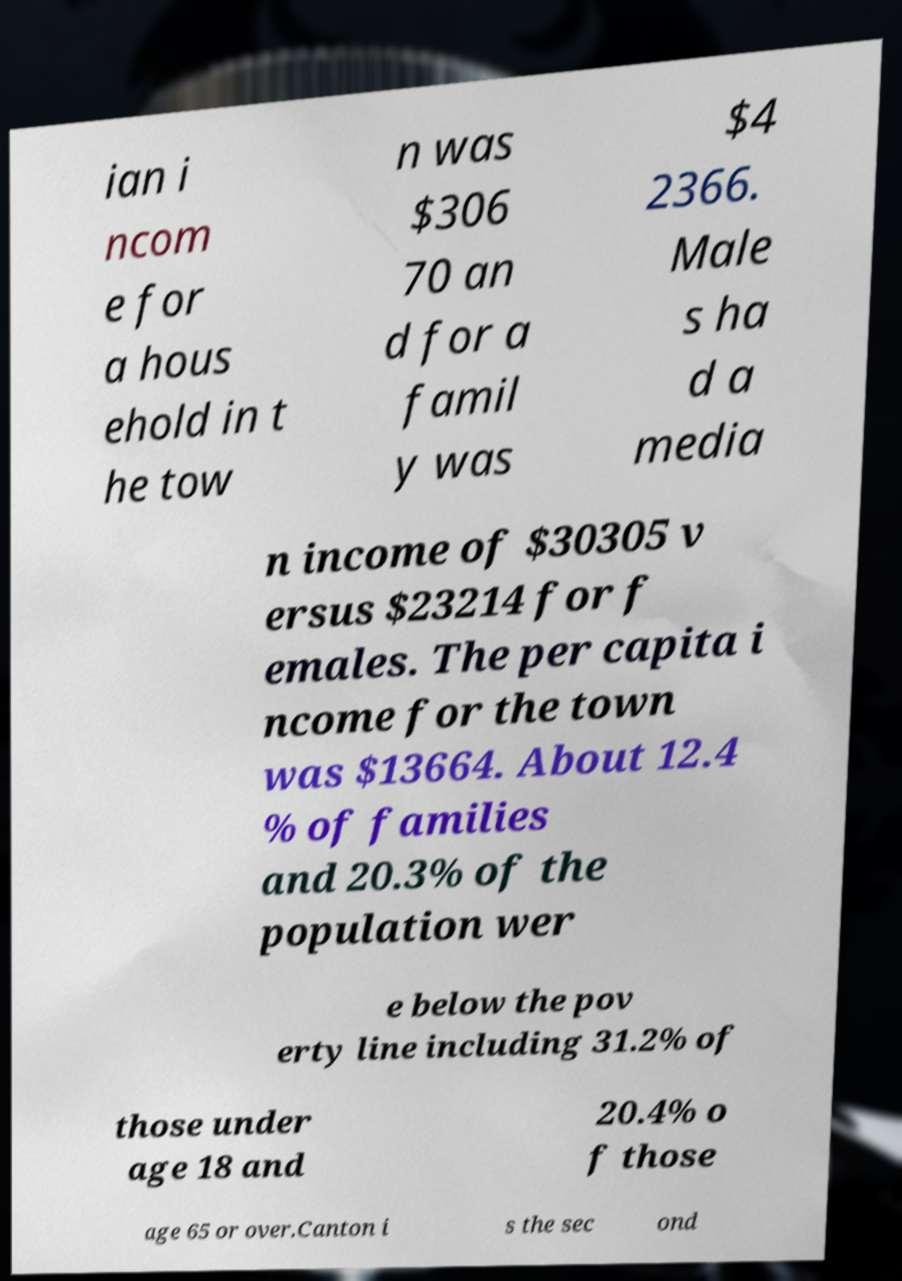For documentation purposes, I need the text within this image transcribed. Could you provide that? ian i ncom e for a hous ehold in t he tow n was $306 70 an d for a famil y was $4 2366. Male s ha d a media n income of $30305 v ersus $23214 for f emales. The per capita i ncome for the town was $13664. About 12.4 % of families and 20.3% of the population wer e below the pov erty line including 31.2% of those under age 18 and 20.4% o f those age 65 or over.Canton i s the sec ond 